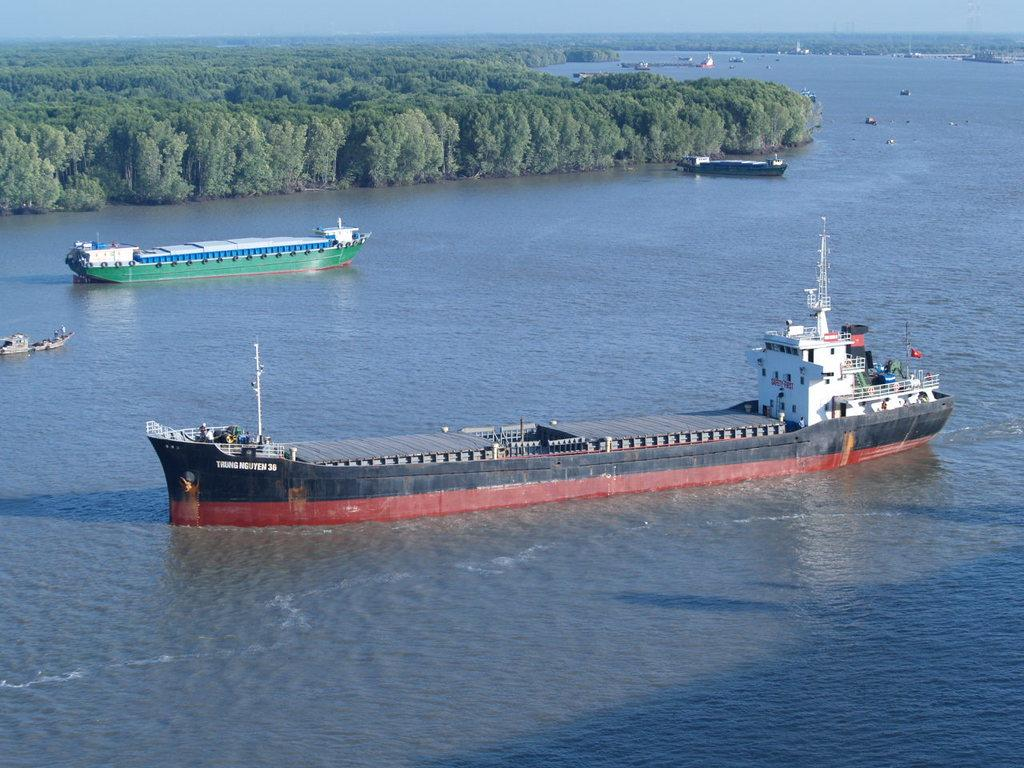What is present at the bottom of the image? There is water at the bottom of the image. What can be seen in the foreground of the image? There are ships in the foreground of the image. What type of vegetation is visible in the background of the image? There are trees in the background of the image. What else can be seen in the background of the image besides trees? There are ships in the background of the image. What is visible at the top of the image? The sky is visible at the top of the image. Who is the manager of the appliance in the image? There is no appliance present in the image, so there is no manager to discuss. What type of work is being done by the ships in the image? The image does not provide information about the ships' activities or purpose, so it cannot determine the type of work being done. 